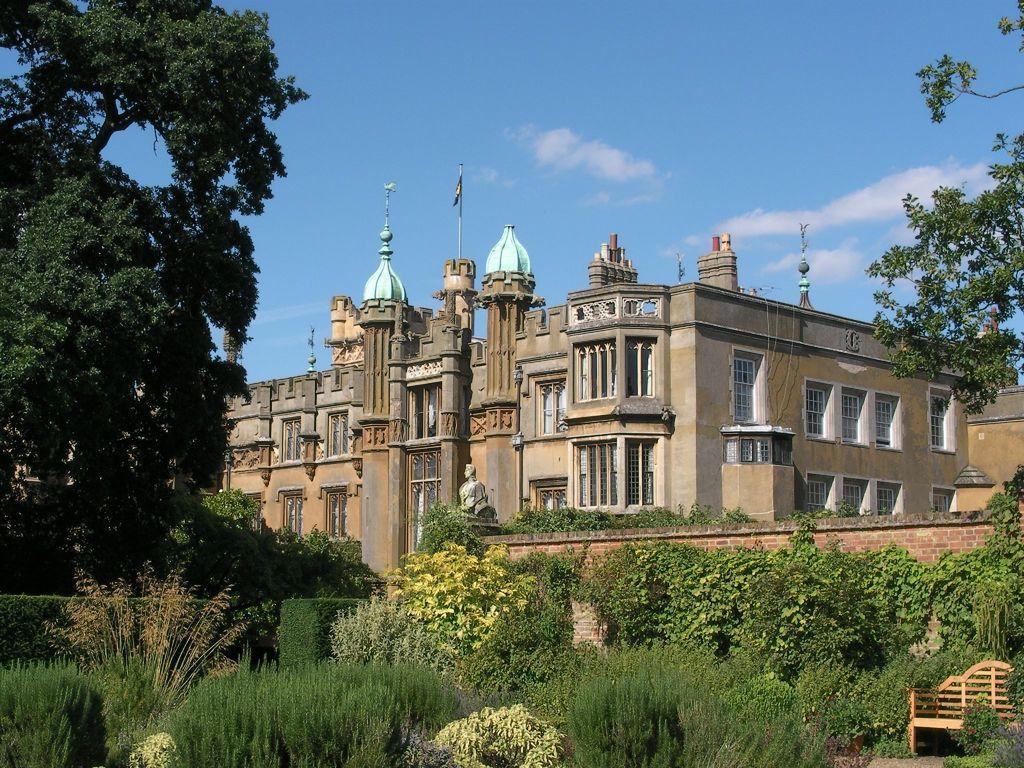In one or two sentences, can you explain what this image depicts? This image consists of a building along with windows. At the bottom, there are plants. On the left and right, there are trees. At the top of the building there is a flag. And we can see the clouds in the sky. 